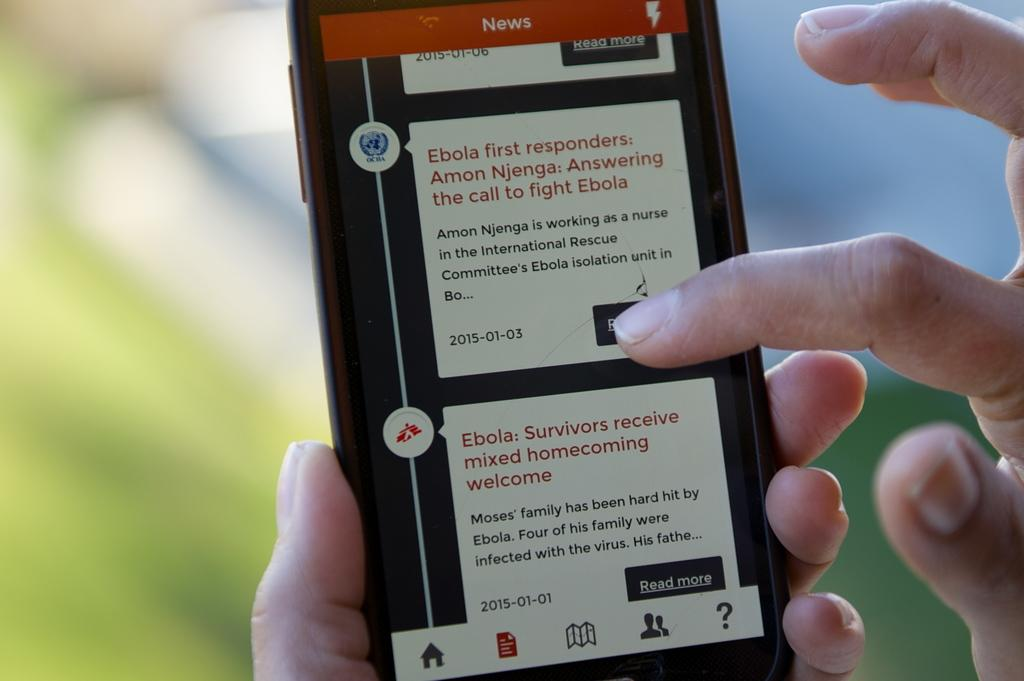<image>
Describe the image concisely. A finger scrolling on a phone with a news page up and an article that says Ebola: Survivors Receive Mixed Homecoming Welcome. 